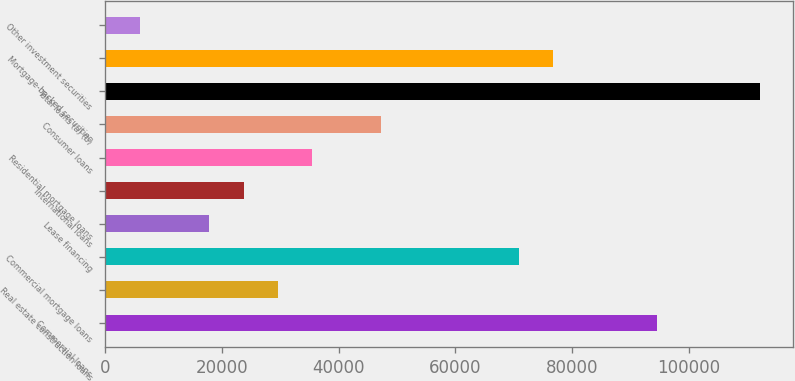<chart> <loc_0><loc_0><loc_500><loc_500><bar_chart><fcel>Commercial loans<fcel>Real estate construction loans<fcel>Commercial mortgage loans<fcel>Lease financing<fcel>International loans<fcel>Residential mortgage loans<fcel>Consumer loans<fcel>Total loans (a) (b)<fcel>Mortgage-backed securities<fcel>Other investment securities<nl><fcel>94478.4<fcel>29601.5<fcel>70886.8<fcel>17805.7<fcel>23703.6<fcel>35499.4<fcel>47295.2<fcel>112172<fcel>76784.7<fcel>6009.9<nl></chart> 